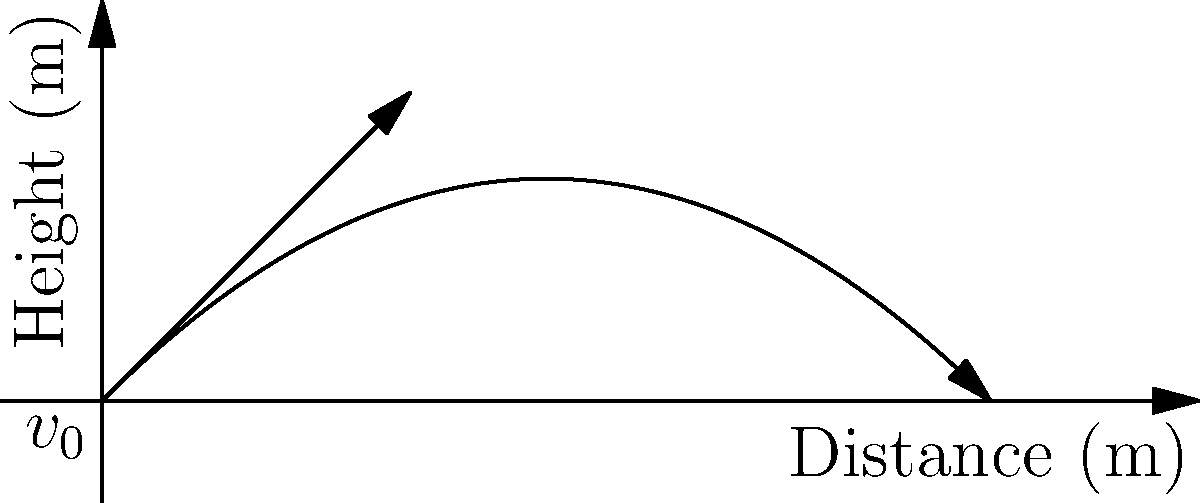A champagne cork is launched from a bottle at an initial velocity of 20 m/s at a 45-degree angle. Assuming no air resistance, what is the maximum height reached by the cork? Use g = 9.8 m/s². To find the maximum height, we'll follow these steps:

1) The vertical component of the initial velocity is:
   $v_{0y} = v_0 \sin \theta = 20 \cdot \sin(45°) = 20 \cdot \frac{\sqrt{2}}{2} \approx 14.14$ m/s

2) The time to reach the maximum height is when the vertical velocity becomes zero:
   $v_y = v_{0y} - gt = 0$
   $t = \frac{v_{0y}}{g} = \frac{14.14}{9.8} \approx 1.44$ seconds

3) The maximum height is found using the equation:
   $y = v_{0y}t - \frac{1}{2}gt^2$

4) Substituting the values:
   $y = 14.14 \cdot 1.44 - \frac{1}{2} \cdot 9.8 \cdot 1.44^2$
   $y = 20.36 - 10.18 = 10.18$ meters

Therefore, the maximum height reached by the champagne cork is approximately 10.18 meters.
Answer: 10.18 meters 